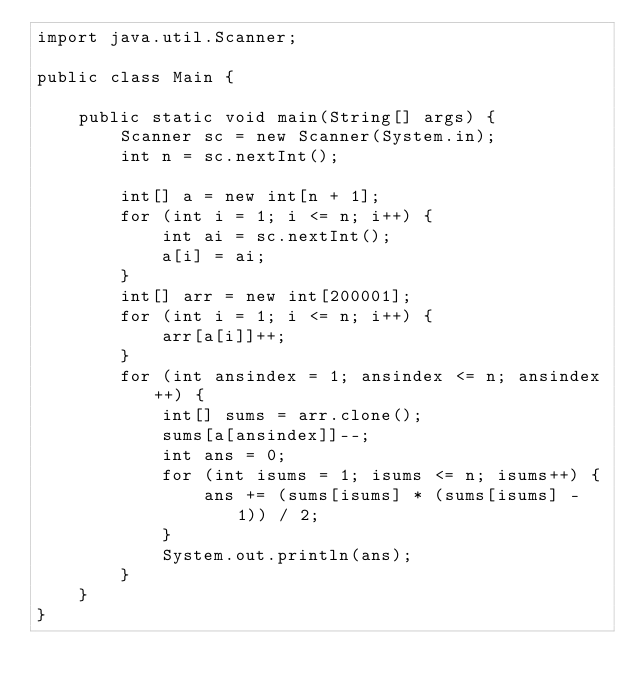<code> <loc_0><loc_0><loc_500><loc_500><_Java_>import java.util.Scanner;

public class Main {

    public static void main(String[] args) {
        Scanner sc = new Scanner(System.in);
        int n = sc.nextInt();

        int[] a = new int[n + 1];
        for (int i = 1; i <= n; i++) {
            int ai = sc.nextInt();
            a[i] = ai;
        }
        int[] arr = new int[200001];
        for (int i = 1; i <= n; i++) {
            arr[a[i]]++;
        }
        for (int ansindex = 1; ansindex <= n; ansindex++) {
            int[] sums = arr.clone();
            sums[a[ansindex]]--;
            int ans = 0;
            for (int isums = 1; isums <= n; isums++) {
                ans += (sums[isums] * (sums[isums] - 1)) / 2;
            }
            System.out.println(ans);
        }
    }
}</code> 